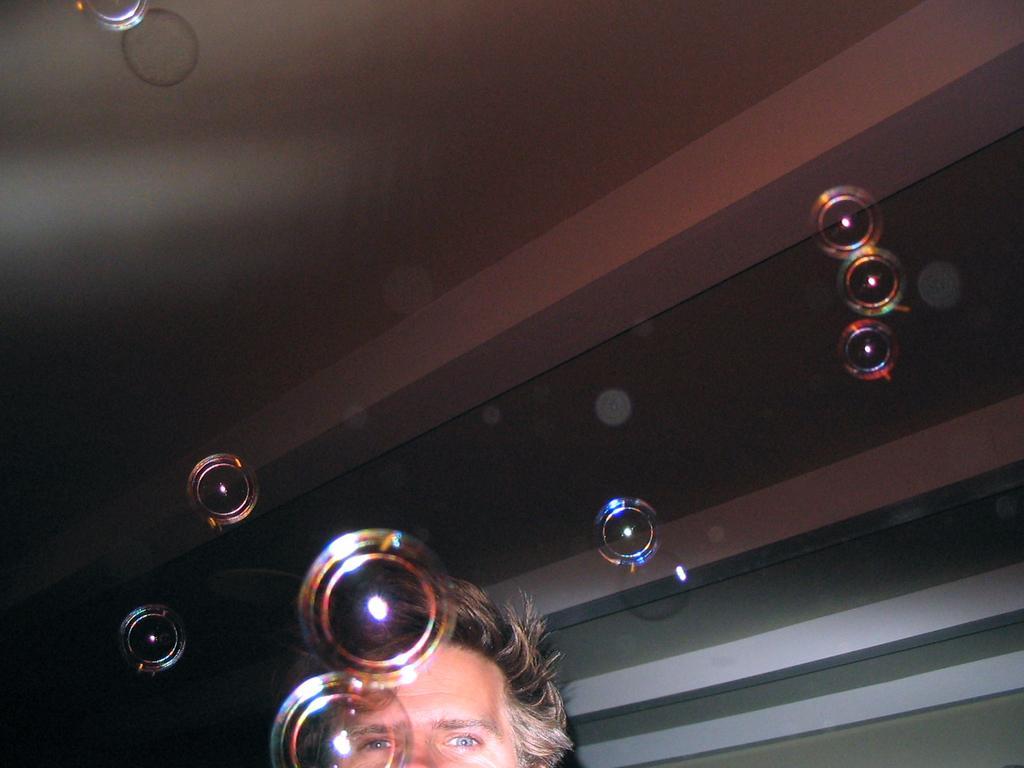In one or two sentences, can you explain what this image depicts? At the bottom of this image, there is a person. In the background, there are lights arranged, there is a roof and there is a wall. 